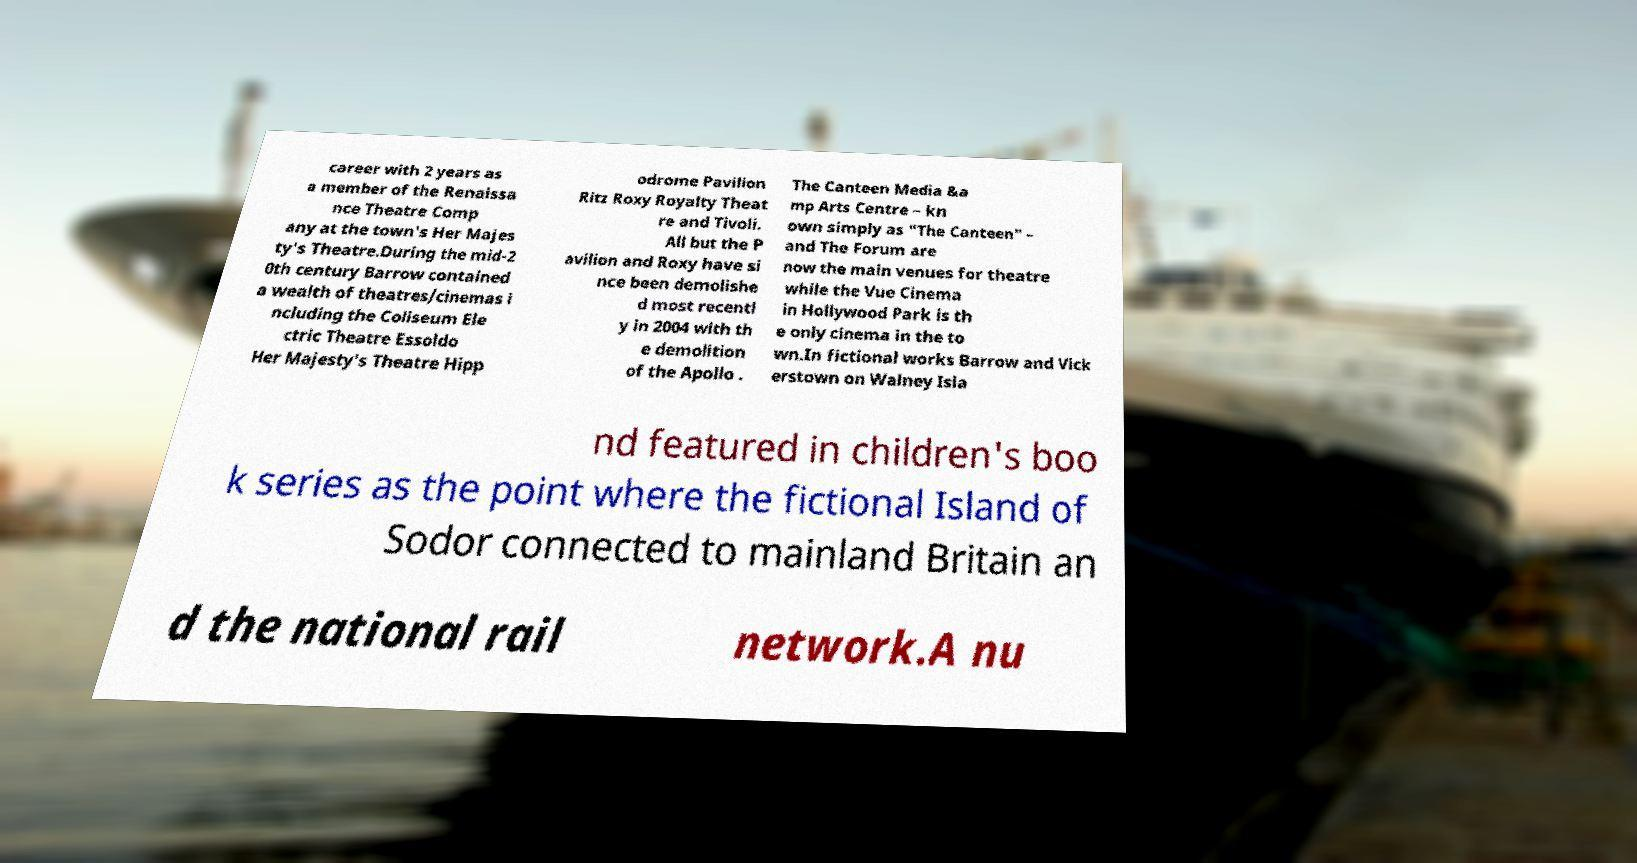Can you accurately transcribe the text from the provided image for me? career with 2 years as a member of the Renaissa nce Theatre Comp any at the town's Her Majes ty's Theatre.During the mid-2 0th century Barrow contained a wealth of theatres/cinemas i ncluding the Coliseum Ele ctric Theatre Essoldo Her Majesty's Theatre Hipp odrome Pavilion Ritz Roxy Royalty Theat re and Tivoli. All but the P avilion and Roxy have si nce been demolishe d most recentl y in 2004 with th e demolition of the Apollo . The Canteen Media &a mp Arts Centre – kn own simply as "The Canteen" – and The Forum are now the main venues for theatre while the Vue Cinema in Hollywood Park is th e only cinema in the to wn.In fictional works Barrow and Vick erstown on Walney Isla nd featured in children's boo k series as the point where the fictional Island of Sodor connected to mainland Britain an d the national rail network.A nu 